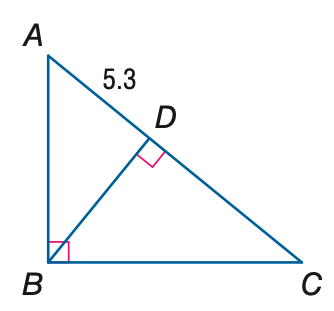Answer the mathemtical geometry problem and directly provide the correct option letter.
Question: The orthocenter of \triangle A B C is located 6.4 units from point D. Find B C.
Choices: A: 4.33 B: 6.40 C: 10.03 D: 20.25 C 